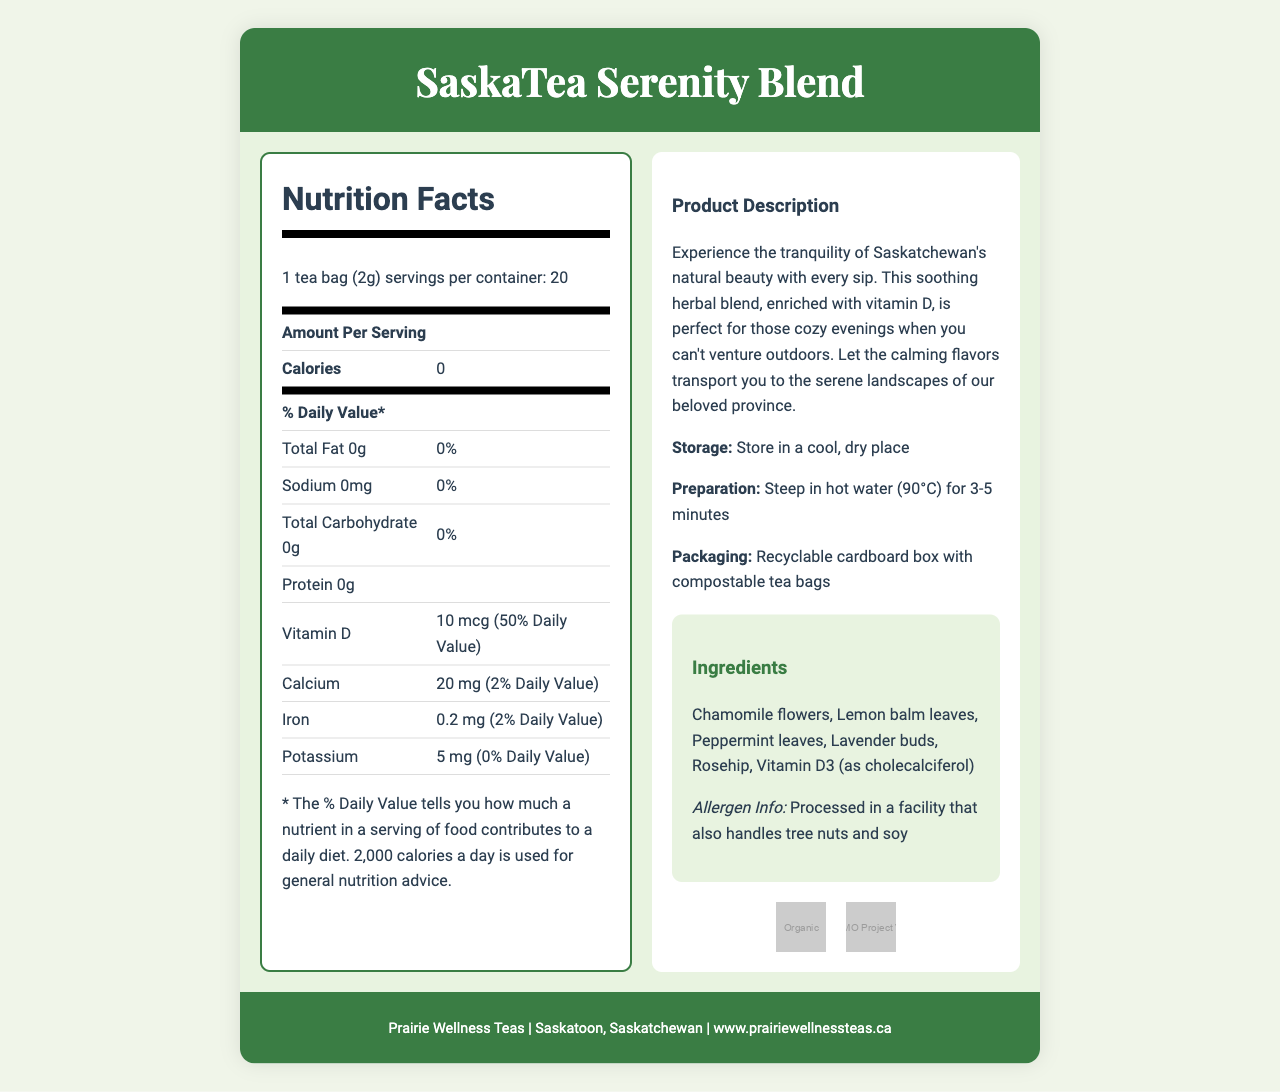what is the serving size of SaskaTea Serenity Blend? The document specifies that the serving size is 1 tea bag (2g).
Answer: 1 tea bag (2g) how many servings are in each container of this tea? The document states that there are 20 servings per container.
Answer: 20 how many calories are in one serving of this tea? The document lists the number of calories as 0 per serving.
Answer: 0 what is the amount of vitamin D per serving, and its daily value percentage? The document indicates that each serving contains 10 mcg of vitamin D, which is 50% of the daily value.
Answer: 10 mcg (50% Daily Value) what are the main ingredients in this herbal tea blend? The ingredients listed in the document are Chamomile flowers, Lemon balm leaves, Peppermint leaves, Lavender buds, Rosehip, and Vitamin D3 (as cholecalciferol).
Answer: Chamomile flowers, Lemon balm leaves, Peppermint leaves, Lavender buds, Rosehip, Vitamin D3 (as cholecalciferol) What is the sodium content of this tea? The nutrition facts section shows that the sodium content is 0 mg.
Answer: 0 mg which element is prominently depicted in the watercolor painting on the packaging? A. Cypress Hills B. Waskesiu Lake C. Grasslands D. Wanuskewin The document describes a watercolor painting of Saskatchewan's Waskesiu Lake on the packaging.
Answer: B which certifications does this product have? A. Organic B. Non-GMO Project Verified C. Fair Trade D. Both A and B The document indicates that the product is certified Organic and Non-GMO Project Verified.
Answer: D is this tea processed in a facility that handles allergens? The allergen information states that the tea is processed in a facility that also handles tree nuts and soy.
Answer: Yes summarize the document's main purpose. The document details the SaskaTea Serenity Blend, providing information on its nutrition, ingredients, and other product details, while emphasizing a connection to nature through its design and description.
Answer: Introducing the SaskaTea Serenity Blend, a vitamin D-enriched herbal tea, highlighting its ingredients, nutritional content, preparation, storage, packaging, and connection to Saskatchewan's nature. where can one purchase this tea online? The document does not provide specific information on where to purchase the tea online.
Answer: Not enough information what is the storage recommendation for this tea? The storage recommendation in the document is to store the tea in a cool, dry place.
Answer: Store in a cool, dry place describe the flavor profile and experience one might expect from this tea. The document describes the tea blend as soothing and aims to evoke tranquility, providing a calming experience with its ingredients.
Answer: The tea blend, featuring ingredients like chamomile, lemon balm, peppermint, and lavender, offers a soothing, calming flavor profile reminiscent of Saskatchewan's tranquil landscapes. 